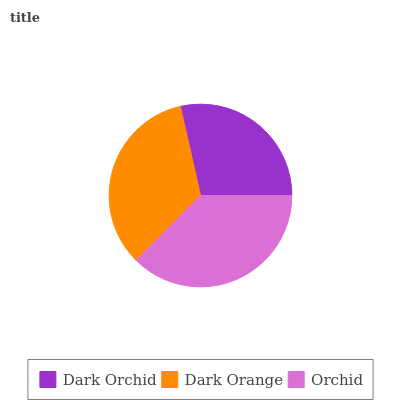Is Dark Orchid the minimum?
Answer yes or no. Yes. Is Orchid the maximum?
Answer yes or no. Yes. Is Dark Orange the minimum?
Answer yes or no. No. Is Dark Orange the maximum?
Answer yes or no. No. Is Dark Orange greater than Dark Orchid?
Answer yes or no. Yes. Is Dark Orchid less than Dark Orange?
Answer yes or no. Yes. Is Dark Orchid greater than Dark Orange?
Answer yes or no. No. Is Dark Orange less than Dark Orchid?
Answer yes or no. No. Is Dark Orange the high median?
Answer yes or no. Yes. Is Dark Orange the low median?
Answer yes or no. Yes. Is Dark Orchid the high median?
Answer yes or no. No. Is Dark Orchid the low median?
Answer yes or no. No. 